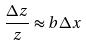Convert formula to latex. <formula><loc_0><loc_0><loc_500><loc_500>\frac { \Delta z } { z } \approx b \Delta x</formula> 